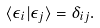<formula> <loc_0><loc_0><loc_500><loc_500>\langle \epsilon _ { i } | \epsilon _ { j } \rangle = \delta _ { i j } .</formula> 